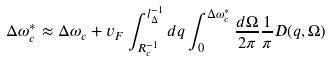<formula> <loc_0><loc_0><loc_500><loc_500>\Delta \omega _ { c } ^ { * } \approx \Delta \omega _ { c } + v _ { F } \int _ { R _ { c } ^ { - 1 } } ^ { l _ { \Delta } ^ { - 1 } } d q \int _ { 0 } ^ { \Delta \omega _ { c } ^ { * } } \frac { d \Omega } { 2 \pi } \frac { 1 } { \pi } D ( { q } , \Omega )</formula> 